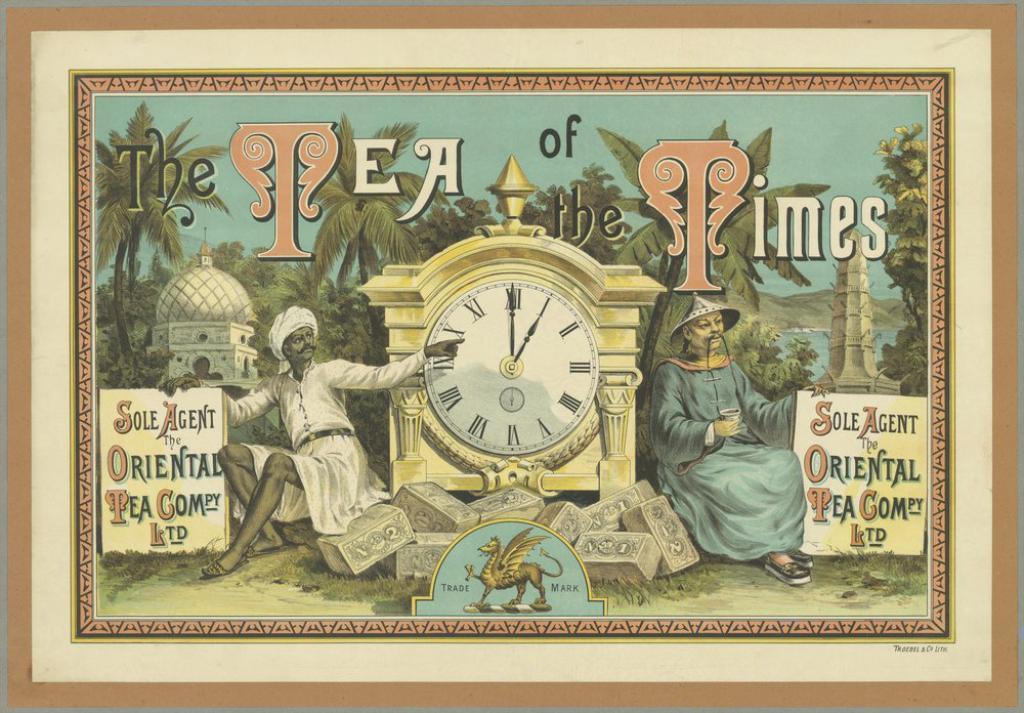What is written on the left hand sign?
Keep it short and to the point. Sole agent oriental pea compy ltd. 